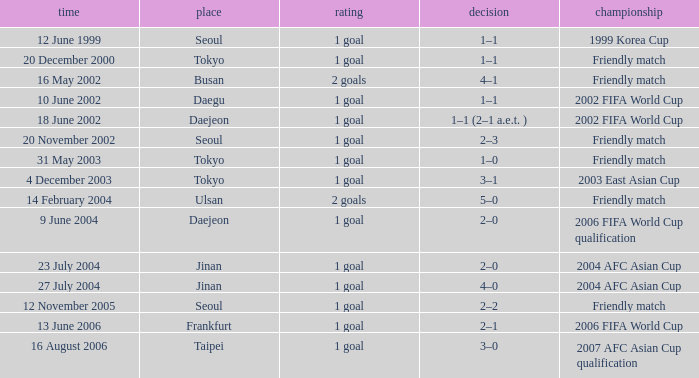What is the venue of the game on 20 November 2002? Seoul. 